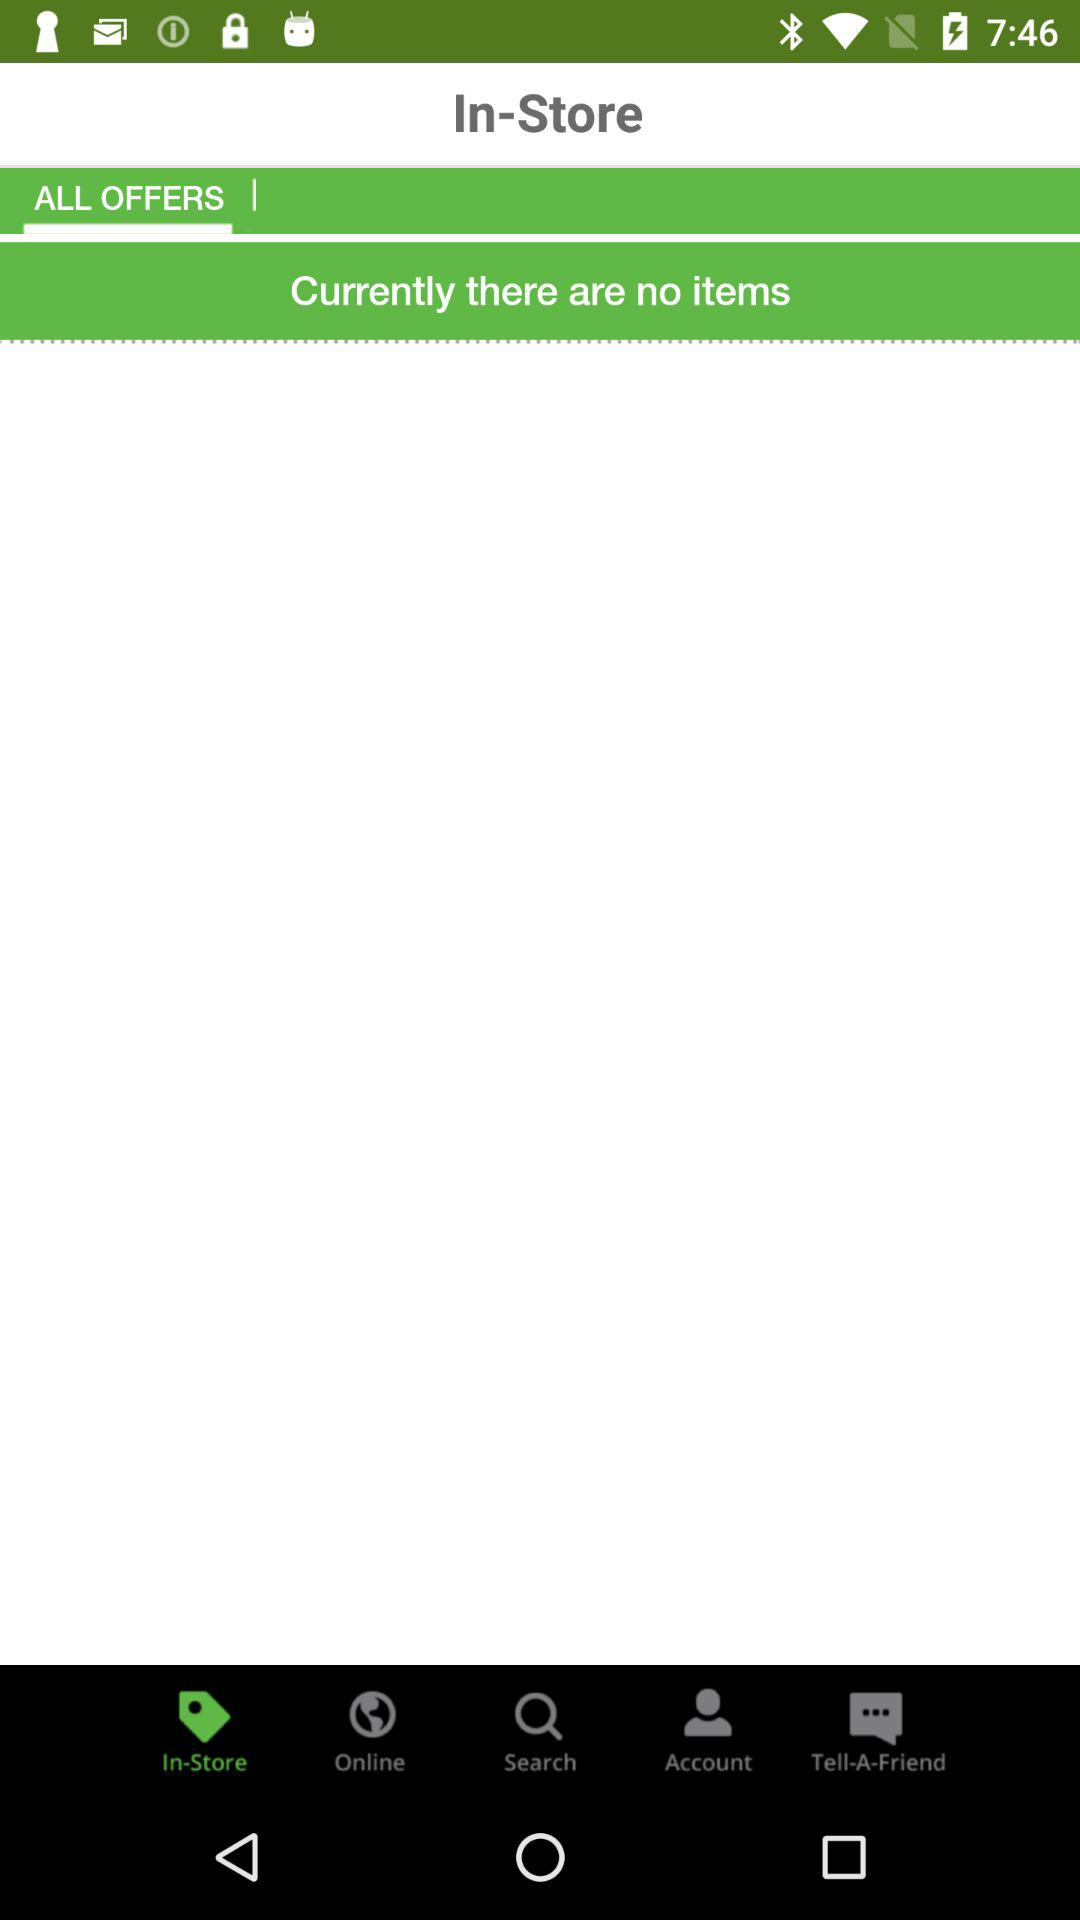Which tab is selected? The selected tab is "ALL OFFERS". 